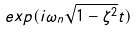<formula> <loc_0><loc_0><loc_500><loc_500>e x p ( i \omega _ { n } \sqrt { 1 - \zeta ^ { 2 } } t )</formula> 